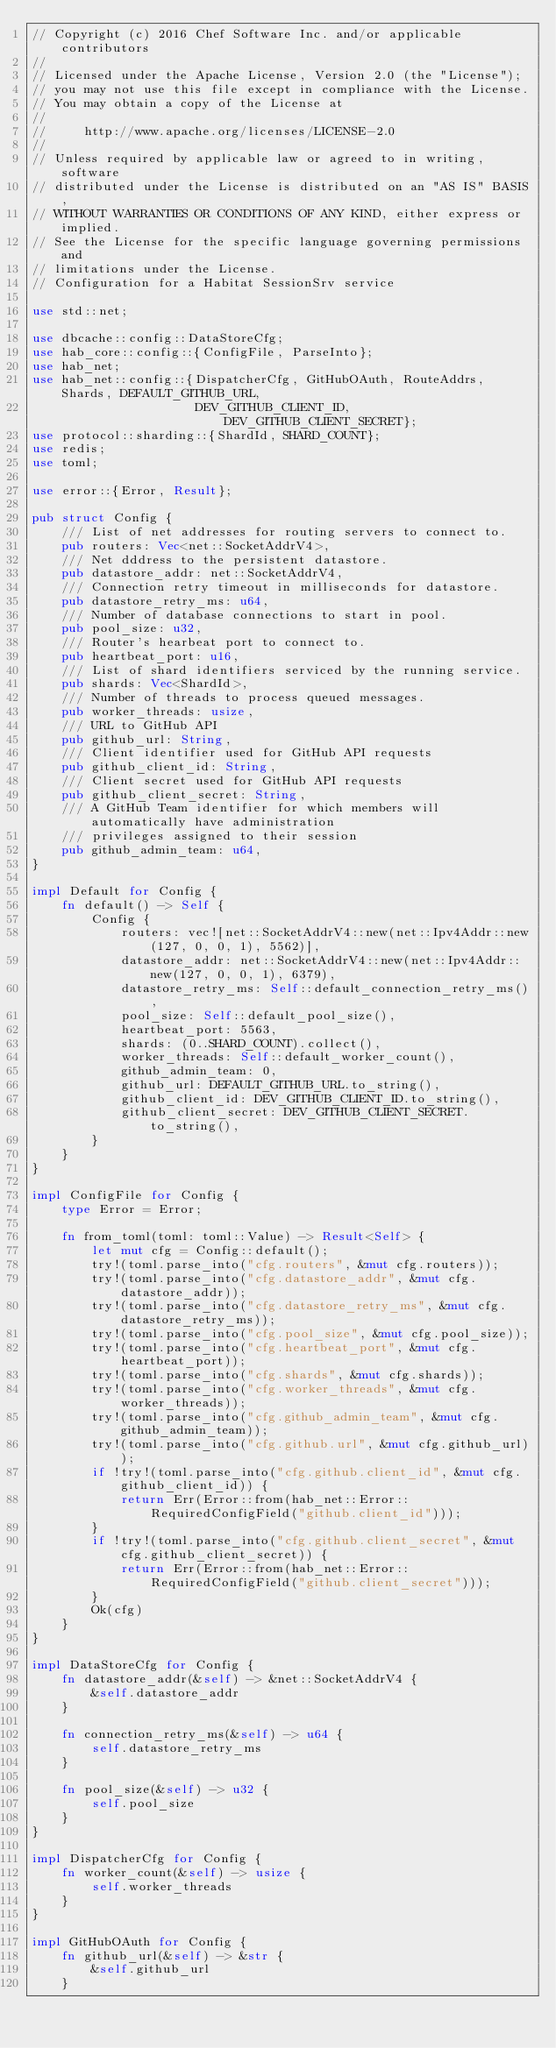Convert code to text. <code><loc_0><loc_0><loc_500><loc_500><_Rust_>// Copyright (c) 2016 Chef Software Inc. and/or applicable contributors
//
// Licensed under the Apache License, Version 2.0 (the "License");
// you may not use this file except in compliance with the License.
// You may obtain a copy of the License at
//
//     http://www.apache.org/licenses/LICENSE-2.0
//
// Unless required by applicable law or agreed to in writing, software
// distributed under the License is distributed on an "AS IS" BASIS,
// WITHOUT WARRANTIES OR CONDITIONS OF ANY KIND, either express or implied.
// See the License for the specific language governing permissions and
// limitations under the License.
// Configuration for a Habitat SessionSrv service

use std::net;

use dbcache::config::DataStoreCfg;
use hab_core::config::{ConfigFile, ParseInto};
use hab_net;
use hab_net::config::{DispatcherCfg, GitHubOAuth, RouteAddrs, Shards, DEFAULT_GITHUB_URL,
                      DEV_GITHUB_CLIENT_ID, DEV_GITHUB_CLIENT_SECRET};
use protocol::sharding::{ShardId, SHARD_COUNT};
use redis;
use toml;

use error::{Error, Result};

pub struct Config {
    /// List of net addresses for routing servers to connect to.
    pub routers: Vec<net::SocketAddrV4>,
    /// Net dddress to the persistent datastore.
    pub datastore_addr: net::SocketAddrV4,
    /// Connection retry timeout in milliseconds for datastore.
    pub datastore_retry_ms: u64,
    /// Number of database connections to start in pool.
    pub pool_size: u32,
    /// Router's hearbeat port to connect to.
    pub heartbeat_port: u16,
    /// List of shard identifiers serviced by the running service.
    pub shards: Vec<ShardId>,
    /// Number of threads to process queued messages.
    pub worker_threads: usize,
    /// URL to GitHub API
    pub github_url: String,
    /// Client identifier used for GitHub API requests
    pub github_client_id: String,
    /// Client secret used for GitHub API requests
    pub github_client_secret: String,
    /// A GitHub Team identifier for which members will automatically have administration
    /// privileges assigned to their session
    pub github_admin_team: u64,
}

impl Default for Config {
    fn default() -> Self {
        Config {
            routers: vec![net::SocketAddrV4::new(net::Ipv4Addr::new(127, 0, 0, 1), 5562)],
            datastore_addr: net::SocketAddrV4::new(net::Ipv4Addr::new(127, 0, 0, 1), 6379),
            datastore_retry_ms: Self::default_connection_retry_ms(),
            pool_size: Self::default_pool_size(),
            heartbeat_port: 5563,
            shards: (0..SHARD_COUNT).collect(),
            worker_threads: Self::default_worker_count(),
            github_admin_team: 0,
            github_url: DEFAULT_GITHUB_URL.to_string(),
            github_client_id: DEV_GITHUB_CLIENT_ID.to_string(),
            github_client_secret: DEV_GITHUB_CLIENT_SECRET.to_string(),
        }
    }
}

impl ConfigFile for Config {
    type Error = Error;

    fn from_toml(toml: toml::Value) -> Result<Self> {
        let mut cfg = Config::default();
        try!(toml.parse_into("cfg.routers", &mut cfg.routers));
        try!(toml.parse_into("cfg.datastore_addr", &mut cfg.datastore_addr));
        try!(toml.parse_into("cfg.datastore_retry_ms", &mut cfg.datastore_retry_ms));
        try!(toml.parse_into("cfg.pool_size", &mut cfg.pool_size));
        try!(toml.parse_into("cfg.heartbeat_port", &mut cfg.heartbeat_port));
        try!(toml.parse_into("cfg.shards", &mut cfg.shards));
        try!(toml.parse_into("cfg.worker_threads", &mut cfg.worker_threads));
        try!(toml.parse_into("cfg.github_admin_team", &mut cfg.github_admin_team));
        try!(toml.parse_into("cfg.github.url", &mut cfg.github_url));
        if !try!(toml.parse_into("cfg.github.client_id", &mut cfg.github_client_id)) {
            return Err(Error::from(hab_net::Error::RequiredConfigField("github.client_id")));
        }
        if !try!(toml.parse_into("cfg.github.client_secret", &mut cfg.github_client_secret)) {
            return Err(Error::from(hab_net::Error::RequiredConfigField("github.client_secret")));
        }
        Ok(cfg)
    }
}

impl DataStoreCfg for Config {
    fn datastore_addr(&self) -> &net::SocketAddrV4 {
        &self.datastore_addr
    }

    fn connection_retry_ms(&self) -> u64 {
        self.datastore_retry_ms
    }

    fn pool_size(&self) -> u32 {
        self.pool_size
    }
}

impl DispatcherCfg for Config {
    fn worker_count(&self) -> usize {
        self.worker_threads
    }
}

impl GitHubOAuth for Config {
    fn github_url(&self) -> &str {
        &self.github_url
    }
</code> 